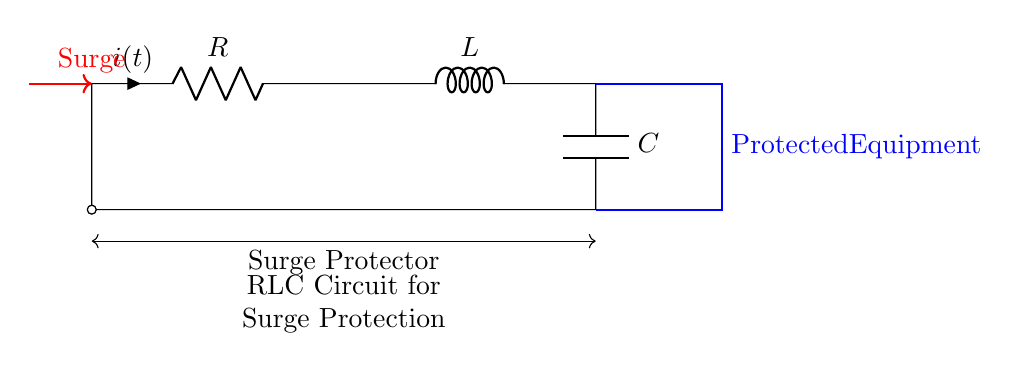What are the components of this circuit? The circuit contains a resistor, an inductor, and a capacitor, which are clearly labeled in the diagram.
Answer: Resistor, Inductor, Capacitor What is the role of the inductor in this circuit? The inductor opposes changes in current, providing a surge protection mechanism by absorbing spikes in voltage.
Answer: Surge protection What does the red arrow indicate? The red arrow indicates a surge, which is the event that the surge protector is designed to handle.
Answer: Surge How do the components connect within the circuit? The resistor connects in series with the inductor, which then connects in series with the capacitor, forming a continuous loop.
Answer: Series connection What is the function of this circuit? The function of the circuit is to protect equipment from voltage surges by using the RLC components effectively.
Answer: Surge protection How does the capacitor behave during a surge? The capacitor stores energy during the surge and releases it, helping to stabilize voltage across the protected equipment.
Answer: Stores energy Which component provides resistance in the circuit? The resistor provides resistance in the circuit, as labeled in the diagram.
Answer: Resistor 